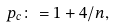<formula> <loc_0><loc_0><loc_500><loc_500>p _ { c } \colon = 1 + 4 / n ,</formula> 